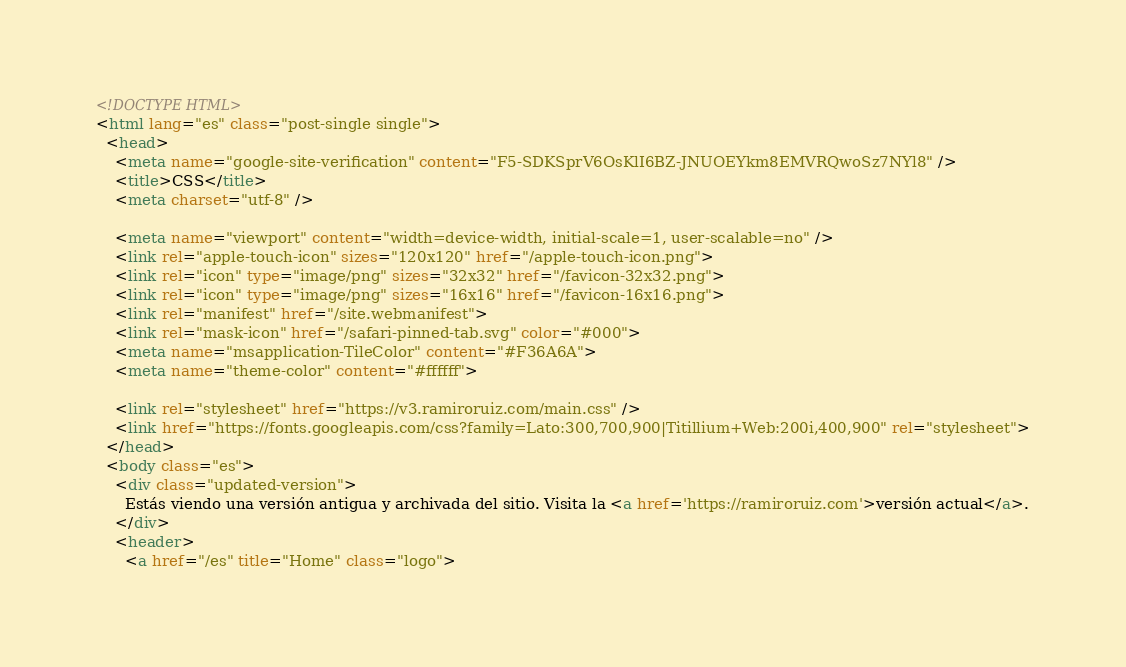<code> <loc_0><loc_0><loc_500><loc_500><_HTML_><!DOCTYPE HTML>
<html lang="es" class="post-single single">
  <head>
    <meta name="google-site-verification" content="F5-SDKSprV6OsKlI6BZ-JNUOEYkm8EMVRQwoSz7NYl8" />
    <title>CSS</title>
    <meta charset="utf-8" />
    
    <meta name="viewport" content="width=device-width, initial-scale=1, user-scalable=no" />
    <link rel="apple-touch-icon" sizes="120x120" href="/apple-touch-icon.png">
    <link rel="icon" type="image/png" sizes="32x32" href="/favicon-32x32.png">
    <link rel="icon" type="image/png" sizes="16x16" href="/favicon-16x16.png">
    <link rel="manifest" href="/site.webmanifest">
    <link rel="mask-icon" href="/safari-pinned-tab.svg" color="#000">
    <meta name="msapplication-TileColor" content="#F36A6A">
    <meta name="theme-color" content="#ffffff">

    <link rel="stylesheet" href="https://v3.ramiroruiz.com/main.css" />
    <link href="https://fonts.googleapis.com/css?family=Lato:300,700,900|Titillium+Web:200i,400,900" rel="stylesheet">
  </head>
  <body class="es">
    <div class="updated-version">
      Estás viendo una versión antigua y archivada del sitio. Visita la <a href='https://ramiroruiz.com'>versión actual</a>.
    </div>
    <header>
      <a href="/es" title="Home" class="logo"></code> 